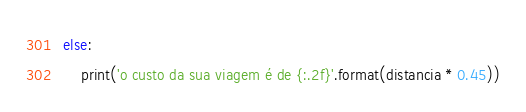Convert code to text. <code><loc_0><loc_0><loc_500><loc_500><_Python_>else:
    print('o custo da sua viagem é de {:.2f}'.format(distancia * 0.45))
</code> 